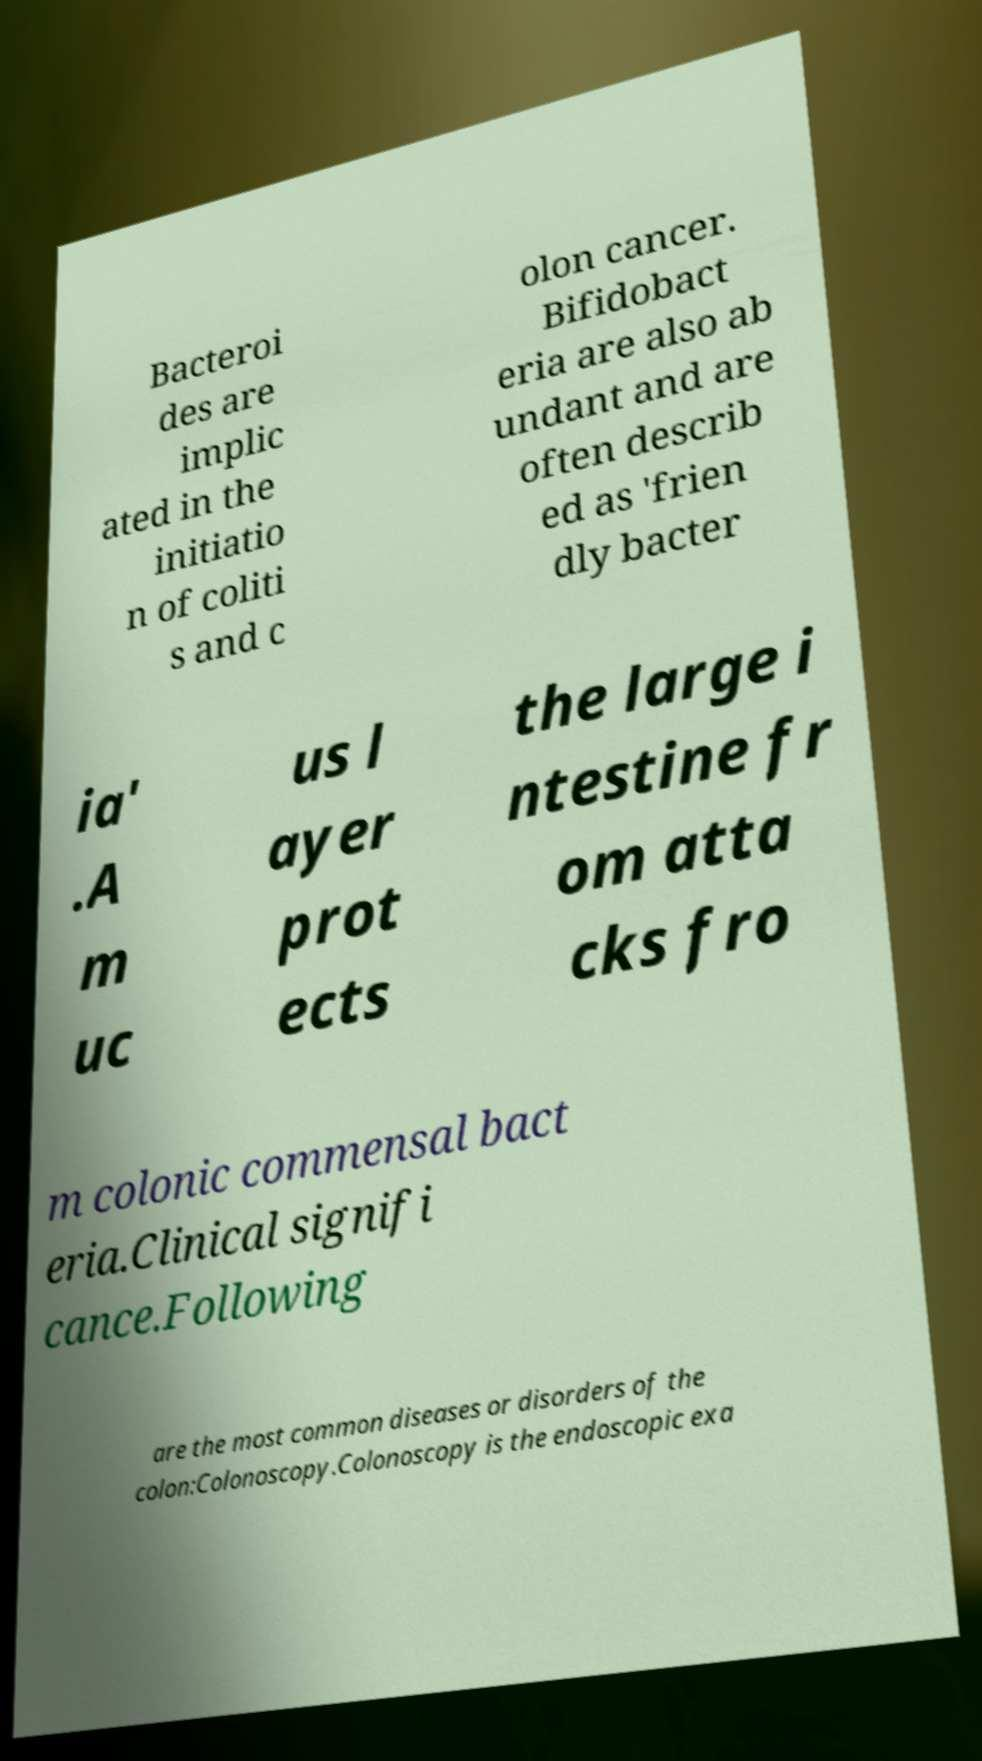For documentation purposes, I need the text within this image transcribed. Could you provide that? Bacteroi des are implic ated in the initiatio n of coliti s and c olon cancer. Bifidobact eria are also ab undant and are often describ ed as 'frien dly bacter ia' .A m uc us l ayer prot ects the large i ntestine fr om atta cks fro m colonic commensal bact eria.Clinical signifi cance.Following are the most common diseases or disorders of the colon:Colonoscopy.Colonoscopy is the endoscopic exa 